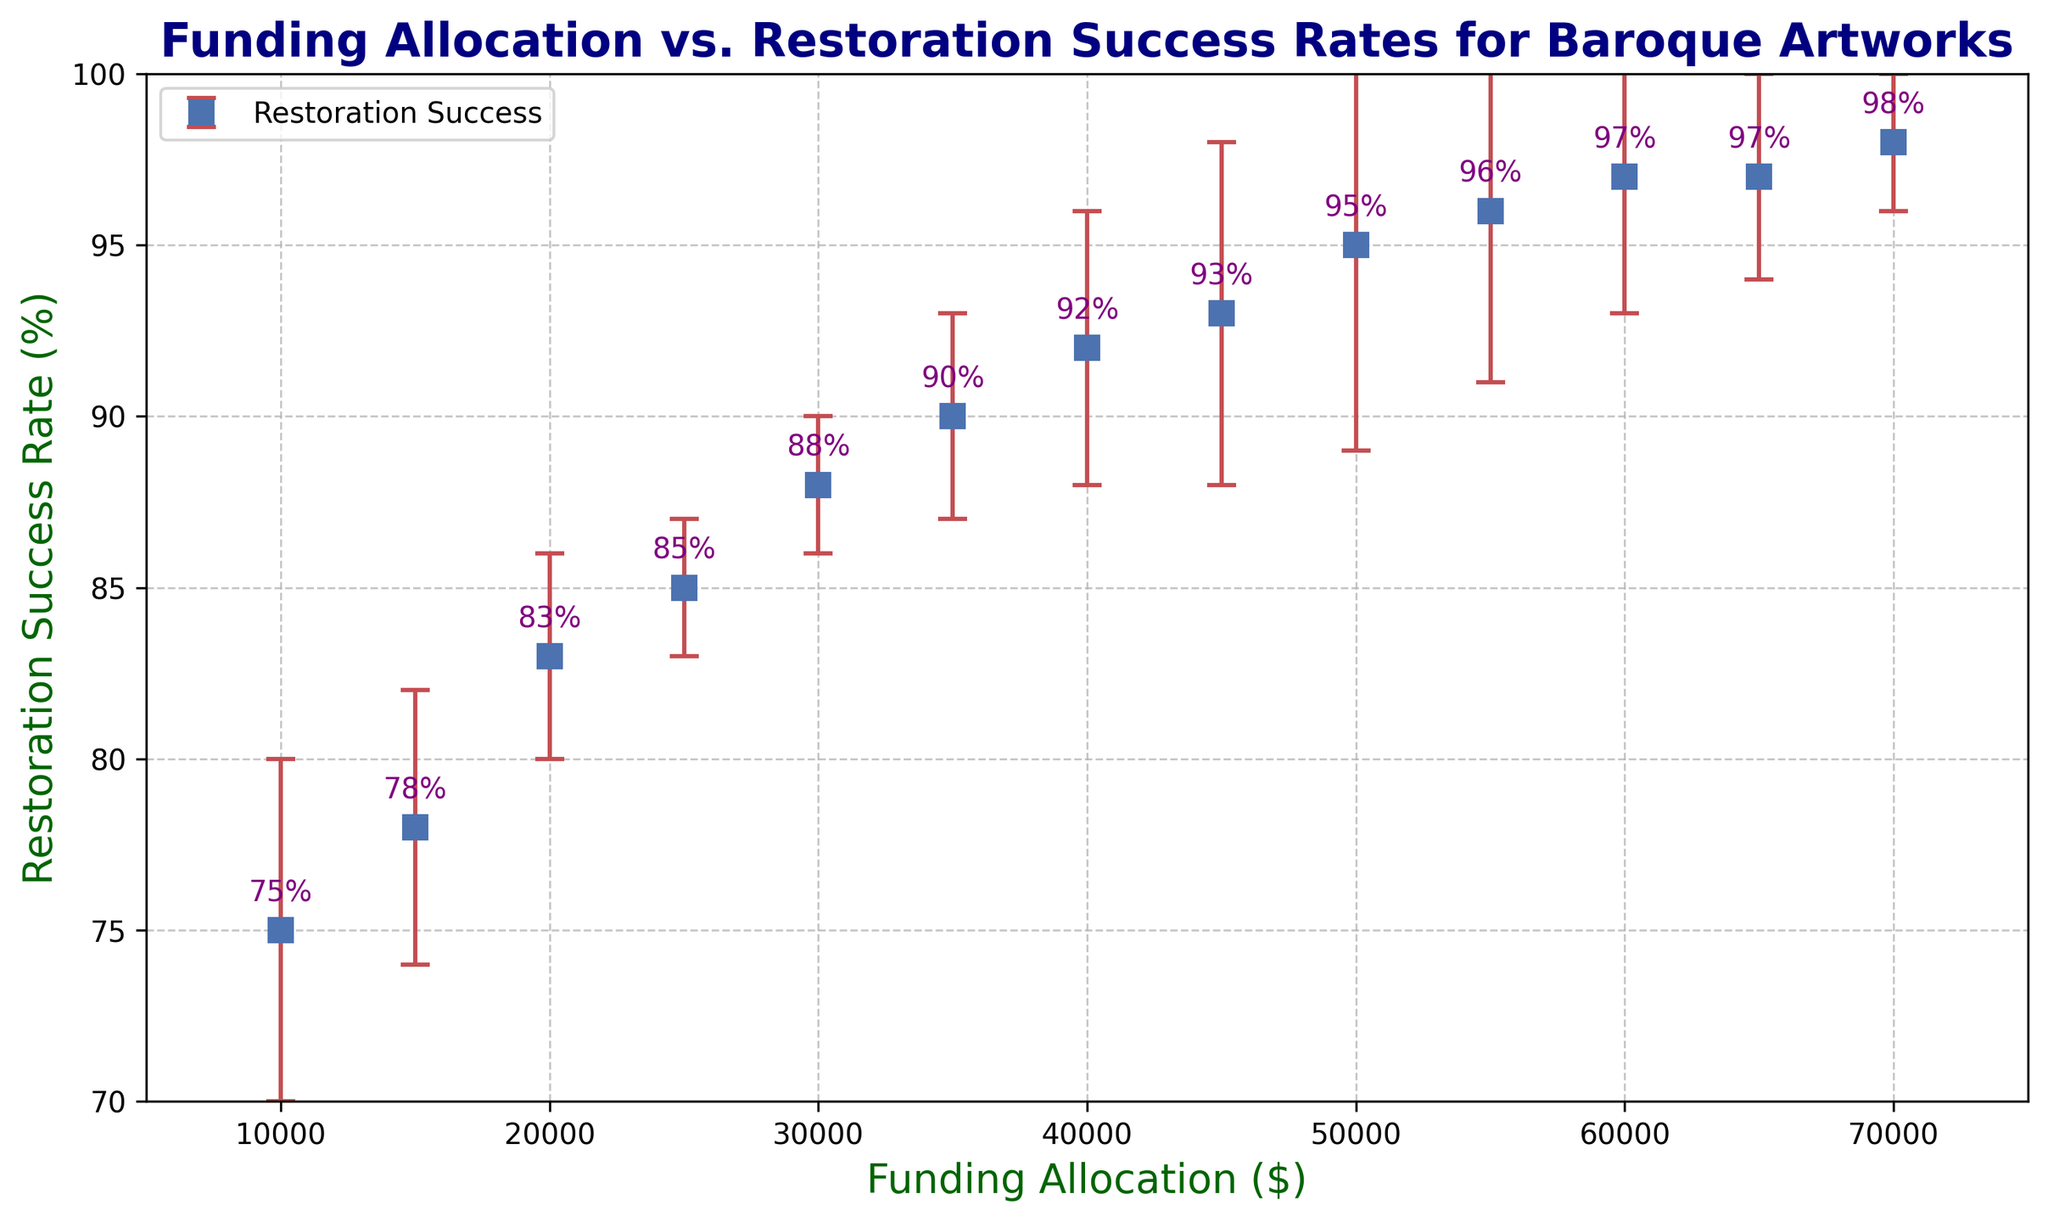What is the average restoration success rate for funding allocations between $20,000 and $40,000? First, identify the success rates for $20,000, $25,000, $30,000, $35,000, and $40,000. The rates are 83%, 85%, 88%, 90%, and 92%. Sum these success rates: 83 + 85 + 88 + 90 + 92 = 438. Then, divide by the number of data points, which is 5. So, 438 / 5 = 87.6
Answer: 87.6 Which funding allocation has the highest restoration success rate? Locate the points on the graph to find the highest success rate. The maximum success rate is 98%, which corresponds to a funding allocation of $70,000.
Answer: $70,000 How much higher is the restoration success rate for $50,000 funding compared to $10,000 funding? The success rate for $10,000 funding is 75%, and for $50,000 funding, it is 95%. Subtract the lower rate from the higher rate: 95% - 75% = 20%.
Answer: 20% At which funding allocation does the restoration success rate first reach 90%? Identify the funding allocations and their corresponding success rates. The success rate first reaches 90% at $35,000.
Answer: $35,000 What is the total restoration success rate (sum of percentages) for the first three funding allocations? The first three funding allocations have success rates of 75%, 78%, and 83%. Sum these rates: 75 + 78 + 83 = 236.
Answer: 236 Between which funding allocations is the increase in restoration success rate the highest? Calculate the increases between consecutive allocations: 78-75=3, 83-78=5, 85-83=2, 88-85=3, 90-88=2, 92-90=2, 93-92=1, 95-93=2, 96-95=1, 97-96=1, 97-97=0, 98-97=1. The highest increase of 5 occurs between $15,000 and $20,000.
Answer: $15,000 and $20,000 What is the standard deviation of the restoration success rate for funding allocations of $30,000, $40,000, and $50,000? The corresponding values are 88%, 92%, and 95%. Calculate the mean: (88 + 92 + 95) / 3 = 91.6667. Then, compute the variance: [(88-91.6667)^2 + (92-91.6667)^2 + (95-91.6667)^2] / 3 = 8.2222. The standard deviation is the square root of the variance: √8.2222 ≈ 2.87
Answer: 2.87 If one mistakenly assumes the error bars represent a fixed value (say, 5%), for which data points is this assumption clearly incorrect? Locate the error bars in the plot. Error bars representing standard deviations vary across data points, e.g., the error bar for $20,000 is 3%, while for $10,000 it is 5%. Any point whose standard deviation is not 5%, such as $20,000 (3%) and $25,000 (2%), shows this assumption is incorrect.
Answer: $20,000, $25,000 